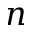Convert formula to latex. <formula><loc_0><loc_0><loc_500><loc_500>n</formula> 